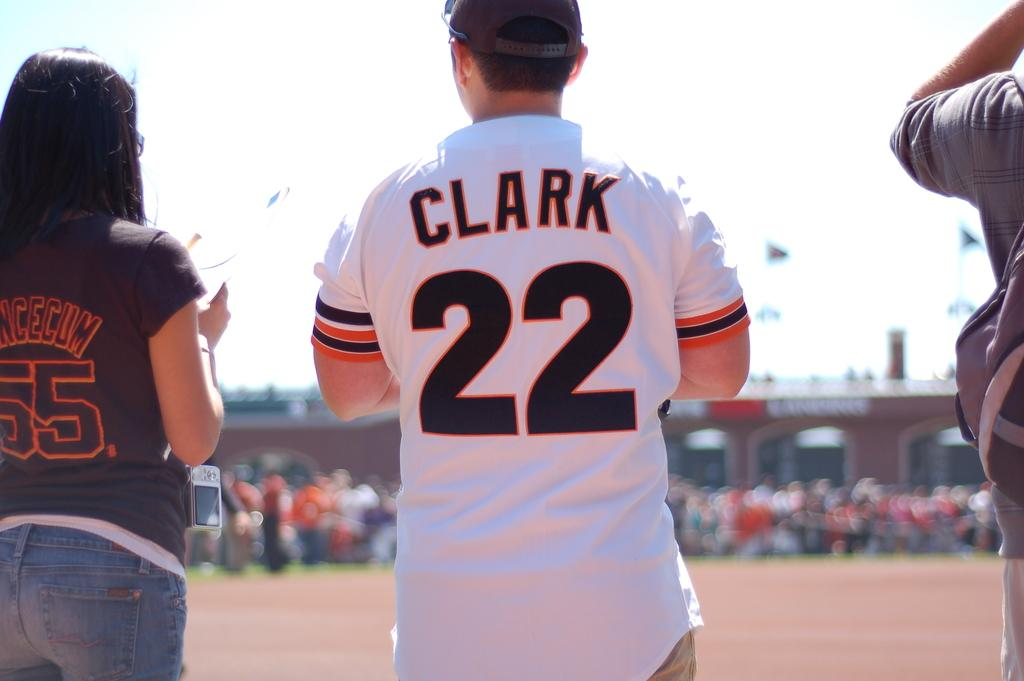Provide a one-sentence caption for the provided image. A man in a baseball cap with his back facing wearing a jersey with the writing CLARK and number 22 with a women with a shirt reading 55 beside him. 